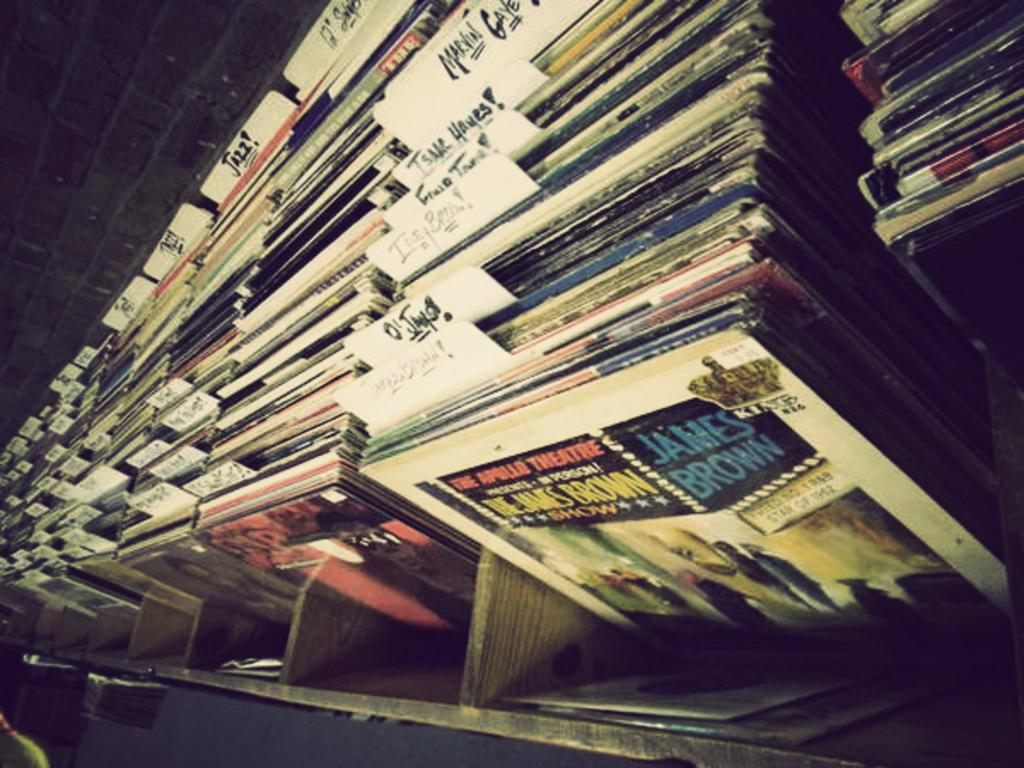<image>
Provide a brief description of the given image. A case that is holding a bunch of records, the first says James Brown on it in blue letters. 